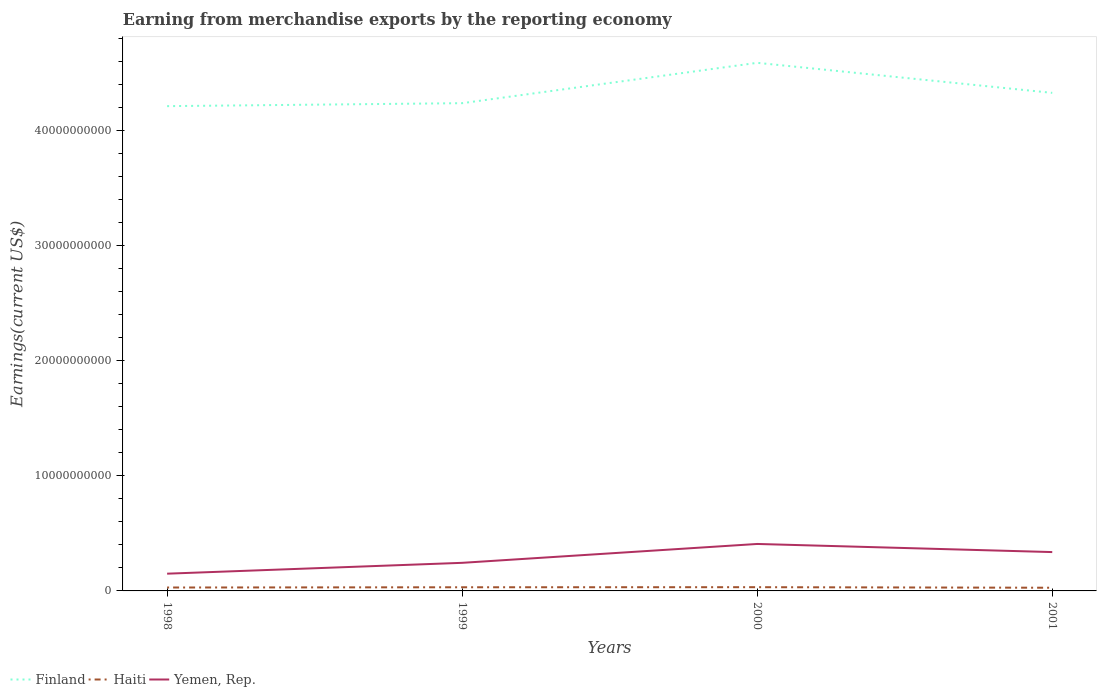Is the number of lines equal to the number of legend labels?
Offer a terse response. Yes. Across all years, what is the maximum amount earned from merchandise exports in Yemen, Rep.?
Your answer should be very brief. 1.50e+09. What is the total amount earned from merchandise exports in Haiti in the graph?
Your answer should be compact. -2.82e+07. What is the difference between the highest and the second highest amount earned from merchandise exports in Finland?
Give a very brief answer. 3.76e+09. What is the difference between the highest and the lowest amount earned from merchandise exports in Haiti?
Ensure brevity in your answer.  2. Is the amount earned from merchandise exports in Yemen, Rep. strictly greater than the amount earned from merchandise exports in Finland over the years?
Your answer should be very brief. Yes. How many lines are there?
Offer a very short reply. 3. How many years are there in the graph?
Provide a short and direct response. 4. Are the values on the major ticks of Y-axis written in scientific E-notation?
Offer a very short reply. No. Does the graph contain any zero values?
Your response must be concise. No. Where does the legend appear in the graph?
Ensure brevity in your answer.  Bottom left. How are the legend labels stacked?
Offer a terse response. Horizontal. What is the title of the graph?
Ensure brevity in your answer.  Earning from merchandise exports by the reporting economy. What is the label or title of the X-axis?
Your answer should be compact. Years. What is the label or title of the Y-axis?
Your answer should be compact. Earnings(current US$). What is the Earnings(current US$) of Finland in 1998?
Provide a short and direct response. 4.21e+1. What is the Earnings(current US$) of Haiti in 1998?
Offer a very short reply. 2.96e+08. What is the Earnings(current US$) in Yemen, Rep. in 1998?
Ensure brevity in your answer.  1.50e+09. What is the Earnings(current US$) in Finland in 1999?
Your answer should be compact. 4.24e+1. What is the Earnings(current US$) of Haiti in 1999?
Offer a very short reply. 3.17e+08. What is the Earnings(current US$) of Yemen, Rep. in 1999?
Keep it short and to the point. 2.44e+09. What is the Earnings(current US$) in Finland in 2000?
Your response must be concise. 4.59e+1. What is the Earnings(current US$) of Haiti in 2000?
Keep it short and to the point. 3.24e+08. What is the Earnings(current US$) in Yemen, Rep. in 2000?
Offer a very short reply. 4.08e+09. What is the Earnings(current US$) of Finland in 2001?
Ensure brevity in your answer.  4.33e+1. What is the Earnings(current US$) in Haiti in 2001?
Keep it short and to the point. 2.77e+08. What is the Earnings(current US$) in Yemen, Rep. in 2001?
Your answer should be compact. 3.37e+09. Across all years, what is the maximum Earnings(current US$) of Finland?
Provide a short and direct response. 4.59e+1. Across all years, what is the maximum Earnings(current US$) of Haiti?
Your answer should be compact. 3.24e+08. Across all years, what is the maximum Earnings(current US$) in Yemen, Rep.?
Provide a short and direct response. 4.08e+09. Across all years, what is the minimum Earnings(current US$) in Finland?
Give a very brief answer. 4.21e+1. Across all years, what is the minimum Earnings(current US$) of Haiti?
Make the answer very short. 2.77e+08. Across all years, what is the minimum Earnings(current US$) of Yemen, Rep.?
Offer a terse response. 1.50e+09. What is the total Earnings(current US$) in Finland in the graph?
Your answer should be very brief. 1.74e+11. What is the total Earnings(current US$) in Haiti in the graph?
Offer a very short reply. 1.21e+09. What is the total Earnings(current US$) of Yemen, Rep. in the graph?
Make the answer very short. 1.14e+1. What is the difference between the Earnings(current US$) of Finland in 1998 and that in 1999?
Make the answer very short. -2.57e+08. What is the difference between the Earnings(current US$) of Haiti in 1998 and that in 1999?
Your answer should be very brief. -2.09e+07. What is the difference between the Earnings(current US$) in Yemen, Rep. in 1998 and that in 1999?
Provide a short and direct response. -9.43e+08. What is the difference between the Earnings(current US$) in Finland in 1998 and that in 2000?
Keep it short and to the point. -3.76e+09. What is the difference between the Earnings(current US$) in Haiti in 1998 and that in 2000?
Make the answer very short. -2.82e+07. What is the difference between the Earnings(current US$) of Yemen, Rep. in 1998 and that in 2000?
Provide a succinct answer. -2.58e+09. What is the difference between the Earnings(current US$) in Finland in 1998 and that in 2001?
Ensure brevity in your answer.  -1.15e+09. What is the difference between the Earnings(current US$) in Haiti in 1998 and that in 2001?
Make the answer very short. 1.95e+07. What is the difference between the Earnings(current US$) in Yemen, Rep. in 1998 and that in 2001?
Your answer should be very brief. -1.88e+09. What is the difference between the Earnings(current US$) in Finland in 1999 and that in 2000?
Keep it short and to the point. -3.51e+09. What is the difference between the Earnings(current US$) in Haiti in 1999 and that in 2000?
Offer a terse response. -7.22e+06. What is the difference between the Earnings(current US$) of Yemen, Rep. in 1999 and that in 2000?
Give a very brief answer. -1.64e+09. What is the difference between the Earnings(current US$) of Finland in 1999 and that in 2001?
Make the answer very short. -8.96e+08. What is the difference between the Earnings(current US$) in Haiti in 1999 and that in 2001?
Offer a terse response. 4.04e+07. What is the difference between the Earnings(current US$) of Yemen, Rep. in 1999 and that in 2001?
Keep it short and to the point. -9.33e+08. What is the difference between the Earnings(current US$) of Finland in 2000 and that in 2001?
Offer a very short reply. 2.61e+09. What is the difference between the Earnings(current US$) of Haiti in 2000 and that in 2001?
Your response must be concise. 4.77e+07. What is the difference between the Earnings(current US$) of Yemen, Rep. in 2000 and that in 2001?
Offer a very short reply. 7.06e+08. What is the difference between the Earnings(current US$) in Finland in 1998 and the Earnings(current US$) in Haiti in 1999?
Offer a terse response. 4.18e+1. What is the difference between the Earnings(current US$) in Finland in 1998 and the Earnings(current US$) in Yemen, Rep. in 1999?
Provide a short and direct response. 3.97e+1. What is the difference between the Earnings(current US$) in Haiti in 1998 and the Earnings(current US$) in Yemen, Rep. in 1999?
Your response must be concise. -2.14e+09. What is the difference between the Earnings(current US$) of Finland in 1998 and the Earnings(current US$) of Haiti in 2000?
Provide a short and direct response. 4.18e+1. What is the difference between the Earnings(current US$) of Finland in 1998 and the Earnings(current US$) of Yemen, Rep. in 2000?
Provide a succinct answer. 3.80e+1. What is the difference between the Earnings(current US$) of Haiti in 1998 and the Earnings(current US$) of Yemen, Rep. in 2000?
Keep it short and to the point. -3.78e+09. What is the difference between the Earnings(current US$) in Finland in 1998 and the Earnings(current US$) in Haiti in 2001?
Your response must be concise. 4.18e+1. What is the difference between the Earnings(current US$) of Finland in 1998 and the Earnings(current US$) of Yemen, Rep. in 2001?
Your answer should be compact. 3.87e+1. What is the difference between the Earnings(current US$) in Haiti in 1998 and the Earnings(current US$) in Yemen, Rep. in 2001?
Give a very brief answer. -3.08e+09. What is the difference between the Earnings(current US$) in Finland in 1999 and the Earnings(current US$) in Haiti in 2000?
Make the answer very short. 4.20e+1. What is the difference between the Earnings(current US$) of Finland in 1999 and the Earnings(current US$) of Yemen, Rep. in 2000?
Your answer should be very brief. 3.83e+1. What is the difference between the Earnings(current US$) in Haiti in 1999 and the Earnings(current US$) in Yemen, Rep. in 2000?
Your answer should be very brief. -3.76e+09. What is the difference between the Earnings(current US$) in Finland in 1999 and the Earnings(current US$) in Haiti in 2001?
Your answer should be very brief. 4.21e+1. What is the difference between the Earnings(current US$) of Finland in 1999 and the Earnings(current US$) of Yemen, Rep. in 2001?
Keep it short and to the point. 3.90e+1. What is the difference between the Earnings(current US$) in Haiti in 1999 and the Earnings(current US$) in Yemen, Rep. in 2001?
Keep it short and to the point. -3.06e+09. What is the difference between the Earnings(current US$) of Finland in 2000 and the Earnings(current US$) of Haiti in 2001?
Offer a very short reply. 4.56e+1. What is the difference between the Earnings(current US$) of Finland in 2000 and the Earnings(current US$) of Yemen, Rep. in 2001?
Provide a short and direct response. 4.25e+1. What is the difference between the Earnings(current US$) of Haiti in 2000 and the Earnings(current US$) of Yemen, Rep. in 2001?
Offer a terse response. -3.05e+09. What is the average Earnings(current US$) of Finland per year?
Your answer should be compact. 4.34e+1. What is the average Earnings(current US$) in Haiti per year?
Keep it short and to the point. 3.04e+08. What is the average Earnings(current US$) of Yemen, Rep. per year?
Ensure brevity in your answer.  2.85e+09. In the year 1998, what is the difference between the Earnings(current US$) in Finland and Earnings(current US$) in Haiti?
Your answer should be compact. 4.18e+1. In the year 1998, what is the difference between the Earnings(current US$) in Finland and Earnings(current US$) in Yemen, Rep.?
Your response must be concise. 4.06e+1. In the year 1998, what is the difference between the Earnings(current US$) in Haiti and Earnings(current US$) in Yemen, Rep.?
Give a very brief answer. -1.20e+09. In the year 1999, what is the difference between the Earnings(current US$) of Finland and Earnings(current US$) of Haiti?
Provide a short and direct response. 4.20e+1. In the year 1999, what is the difference between the Earnings(current US$) of Finland and Earnings(current US$) of Yemen, Rep.?
Your answer should be compact. 3.99e+1. In the year 1999, what is the difference between the Earnings(current US$) of Haiti and Earnings(current US$) of Yemen, Rep.?
Provide a succinct answer. -2.12e+09. In the year 2000, what is the difference between the Earnings(current US$) in Finland and Earnings(current US$) in Haiti?
Keep it short and to the point. 4.55e+1. In the year 2000, what is the difference between the Earnings(current US$) in Finland and Earnings(current US$) in Yemen, Rep.?
Offer a very short reply. 4.18e+1. In the year 2000, what is the difference between the Earnings(current US$) of Haiti and Earnings(current US$) of Yemen, Rep.?
Ensure brevity in your answer.  -3.75e+09. In the year 2001, what is the difference between the Earnings(current US$) in Finland and Earnings(current US$) in Haiti?
Make the answer very short. 4.30e+1. In the year 2001, what is the difference between the Earnings(current US$) of Finland and Earnings(current US$) of Yemen, Rep.?
Make the answer very short. 3.99e+1. In the year 2001, what is the difference between the Earnings(current US$) of Haiti and Earnings(current US$) of Yemen, Rep.?
Give a very brief answer. -3.10e+09. What is the ratio of the Earnings(current US$) in Finland in 1998 to that in 1999?
Your answer should be very brief. 0.99. What is the ratio of the Earnings(current US$) in Haiti in 1998 to that in 1999?
Keep it short and to the point. 0.93. What is the ratio of the Earnings(current US$) of Yemen, Rep. in 1998 to that in 1999?
Offer a very short reply. 0.61. What is the ratio of the Earnings(current US$) of Finland in 1998 to that in 2000?
Make the answer very short. 0.92. What is the ratio of the Earnings(current US$) in Haiti in 1998 to that in 2000?
Your answer should be very brief. 0.91. What is the ratio of the Earnings(current US$) of Yemen, Rep. in 1998 to that in 2000?
Your answer should be very brief. 0.37. What is the ratio of the Earnings(current US$) in Finland in 1998 to that in 2001?
Give a very brief answer. 0.97. What is the ratio of the Earnings(current US$) of Haiti in 1998 to that in 2001?
Ensure brevity in your answer.  1.07. What is the ratio of the Earnings(current US$) of Yemen, Rep. in 1998 to that in 2001?
Keep it short and to the point. 0.44. What is the ratio of the Earnings(current US$) of Finland in 1999 to that in 2000?
Your answer should be very brief. 0.92. What is the ratio of the Earnings(current US$) in Haiti in 1999 to that in 2000?
Your answer should be compact. 0.98. What is the ratio of the Earnings(current US$) of Yemen, Rep. in 1999 to that in 2000?
Make the answer very short. 0.6. What is the ratio of the Earnings(current US$) of Finland in 1999 to that in 2001?
Provide a succinct answer. 0.98. What is the ratio of the Earnings(current US$) in Haiti in 1999 to that in 2001?
Make the answer very short. 1.15. What is the ratio of the Earnings(current US$) in Yemen, Rep. in 1999 to that in 2001?
Your response must be concise. 0.72. What is the ratio of the Earnings(current US$) of Finland in 2000 to that in 2001?
Give a very brief answer. 1.06. What is the ratio of the Earnings(current US$) in Haiti in 2000 to that in 2001?
Your answer should be very brief. 1.17. What is the ratio of the Earnings(current US$) in Yemen, Rep. in 2000 to that in 2001?
Offer a very short reply. 1.21. What is the difference between the highest and the second highest Earnings(current US$) in Finland?
Ensure brevity in your answer.  2.61e+09. What is the difference between the highest and the second highest Earnings(current US$) of Haiti?
Ensure brevity in your answer.  7.22e+06. What is the difference between the highest and the second highest Earnings(current US$) in Yemen, Rep.?
Make the answer very short. 7.06e+08. What is the difference between the highest and the lowest Earnings(current US$) of Finland?
Keep it short and to the point. 3.76e+09. What is the difference between the highest and the lowest Earnings(current US$) of Haiti?
Your answer should be very brief. 4.77e+07. What is the difference between the highest and the lowest Earnings(current US$) in Yemen, Rep.?
Your response must be concise. 2.58e+09. 